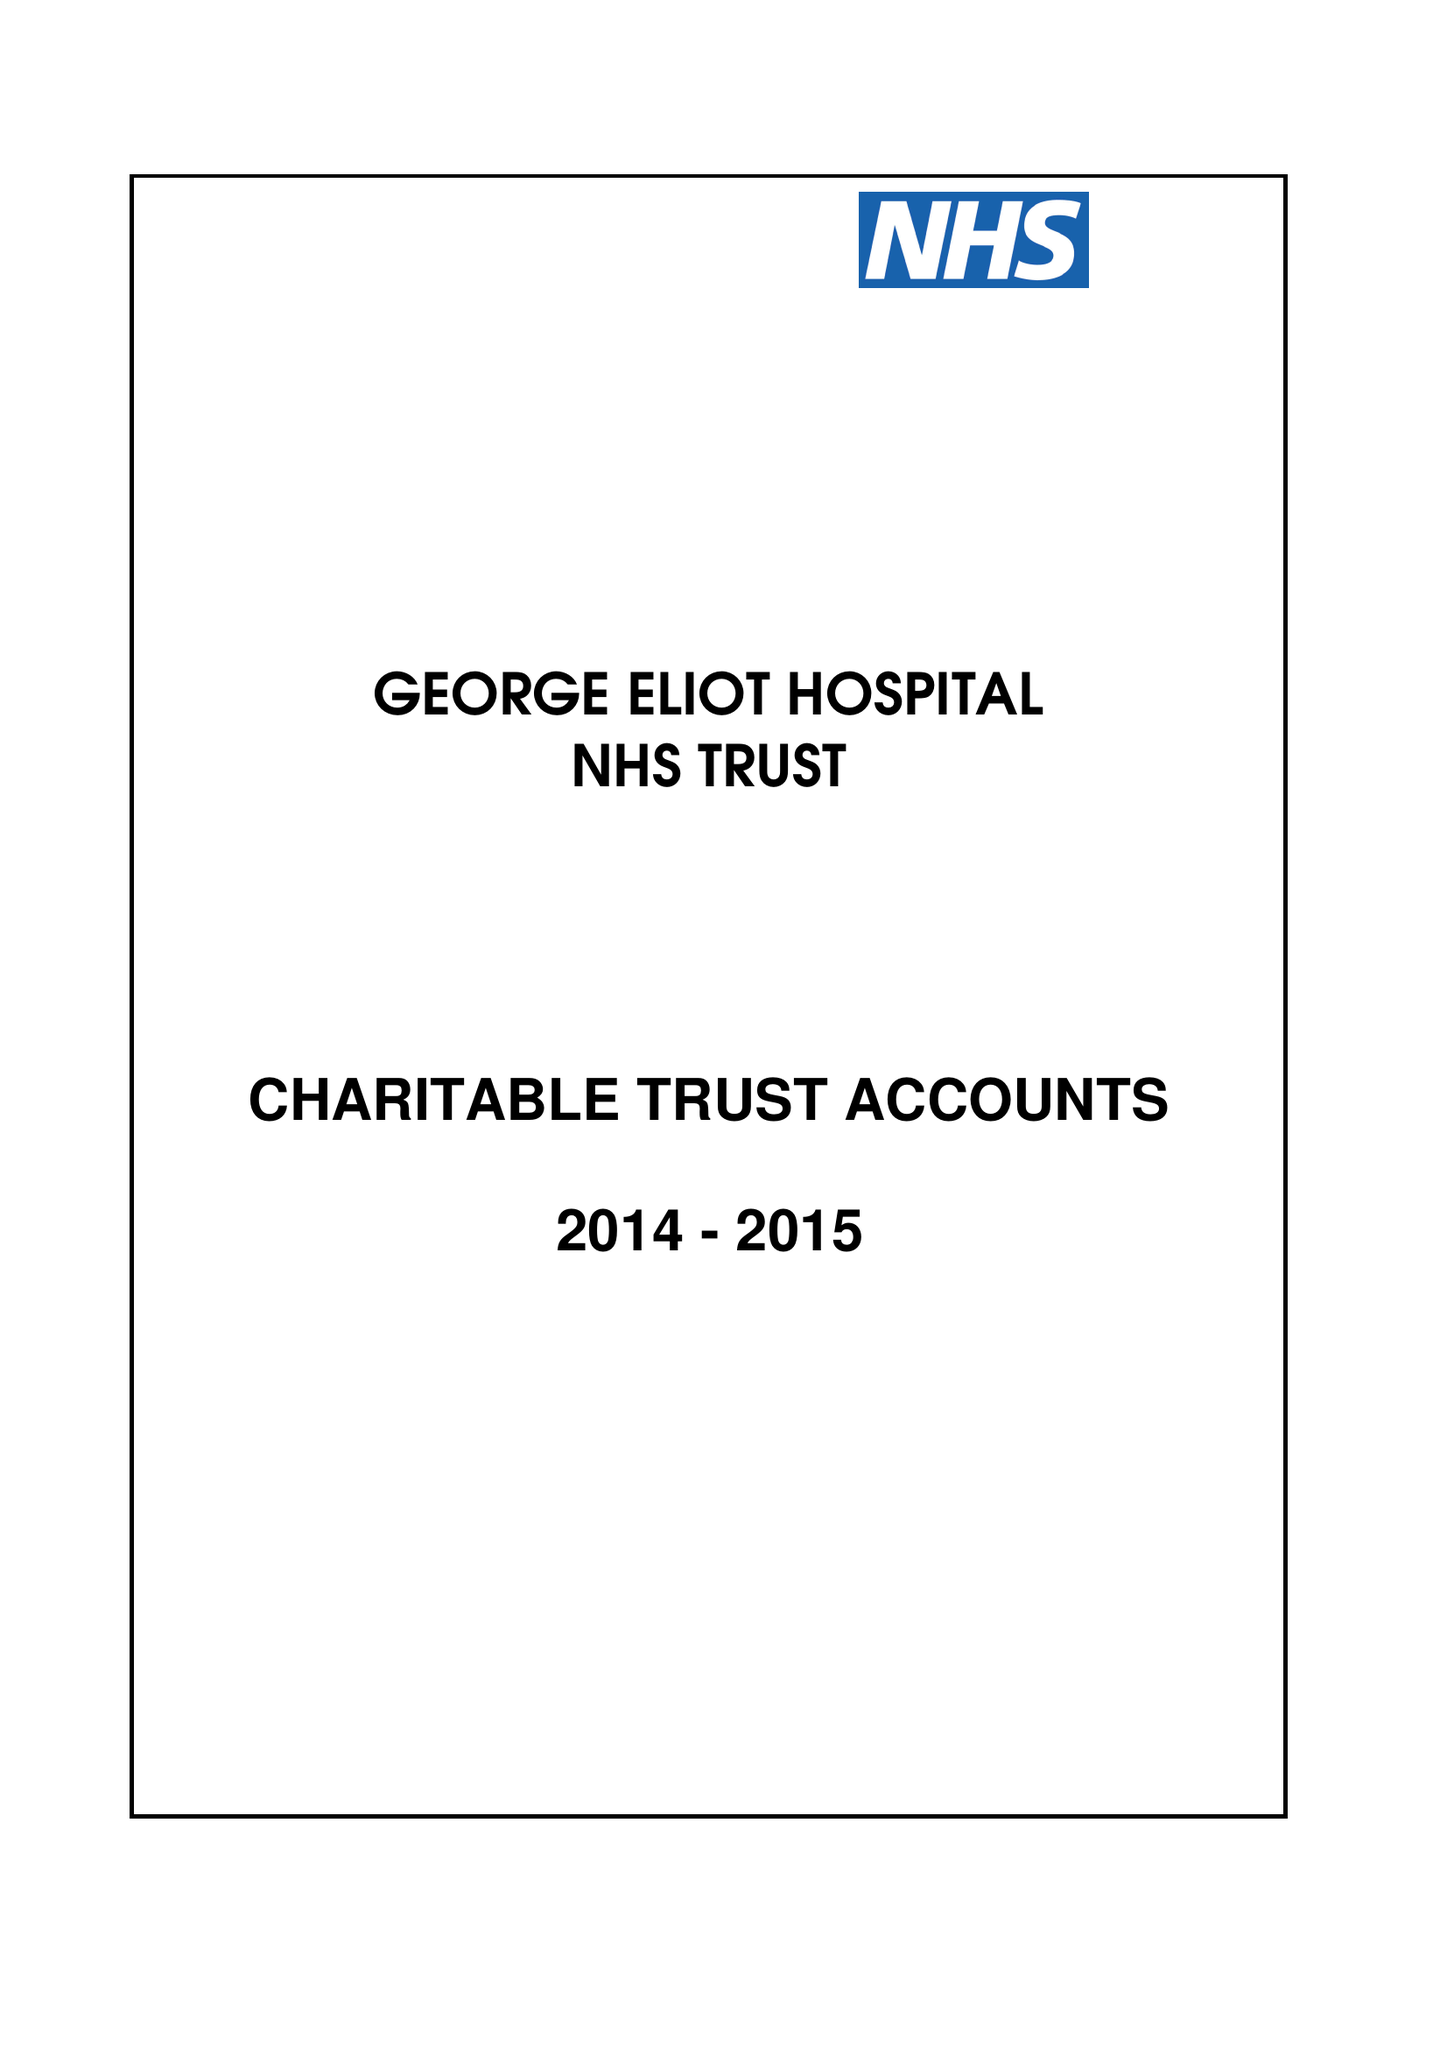What is the value for the report_date?
Answer the question using a single word or phrase. 2015-03-31 